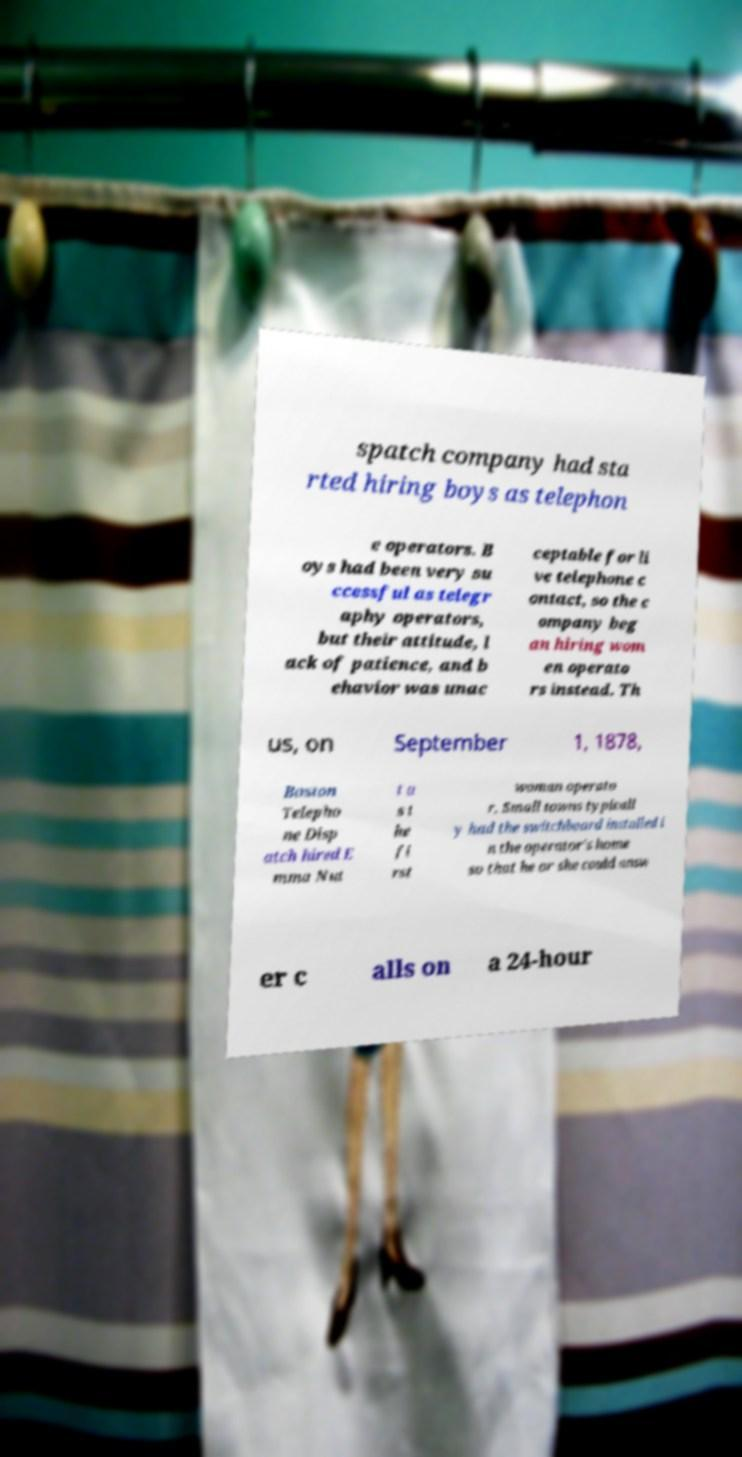Could you extract and type out the text from this image? spatch company had sta rted hiring boys as telephon e operators. B oys had been very su ccessful as telegr aphy operators, but their attitude, l ack of patience, and b ehavior was unac ceptable for li ve telephone c ontact, so the c ompany beg an hiring wom en operato rs instead. Th us, on September 1, 1878, Boston Telepho ne Disp atch hired E mma Nut t a s t he fi rst woman operato r. Small towns typicall y had the switchboard installed i n the operator's home so that he or she could answ er c alls on a 24-hour 